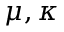<formula> <loc_0><loc_0><loc_500><loc_500>\mu , \kappa</formula> 